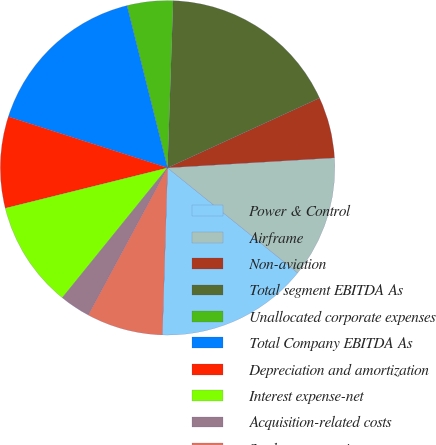Convert chart. <chart><loc_0><loc_0><loc_500><loc_500><pie_chart><fcel>Power & Control<fcel>Airframe<fcel>Non-aviation<fcel>Total segment EBITDA As<fcel>Unallocated corporate expenses<fcel>Total Company EBITDA As<fcel>Depreciation and amortization<fcel>Interest expense-net<fcel>Acquisition-related costs<fcel>Stock compensation expense<nl><fcel>14.69%<fcel>11.76%<fcel>5.9%<fcel>17.62%<fcel>4.43%<fcel>16.15%<fcel>8.83%<fcel>10.29%<fcel>2.97%<fcel>7.36%<nl></chart> 